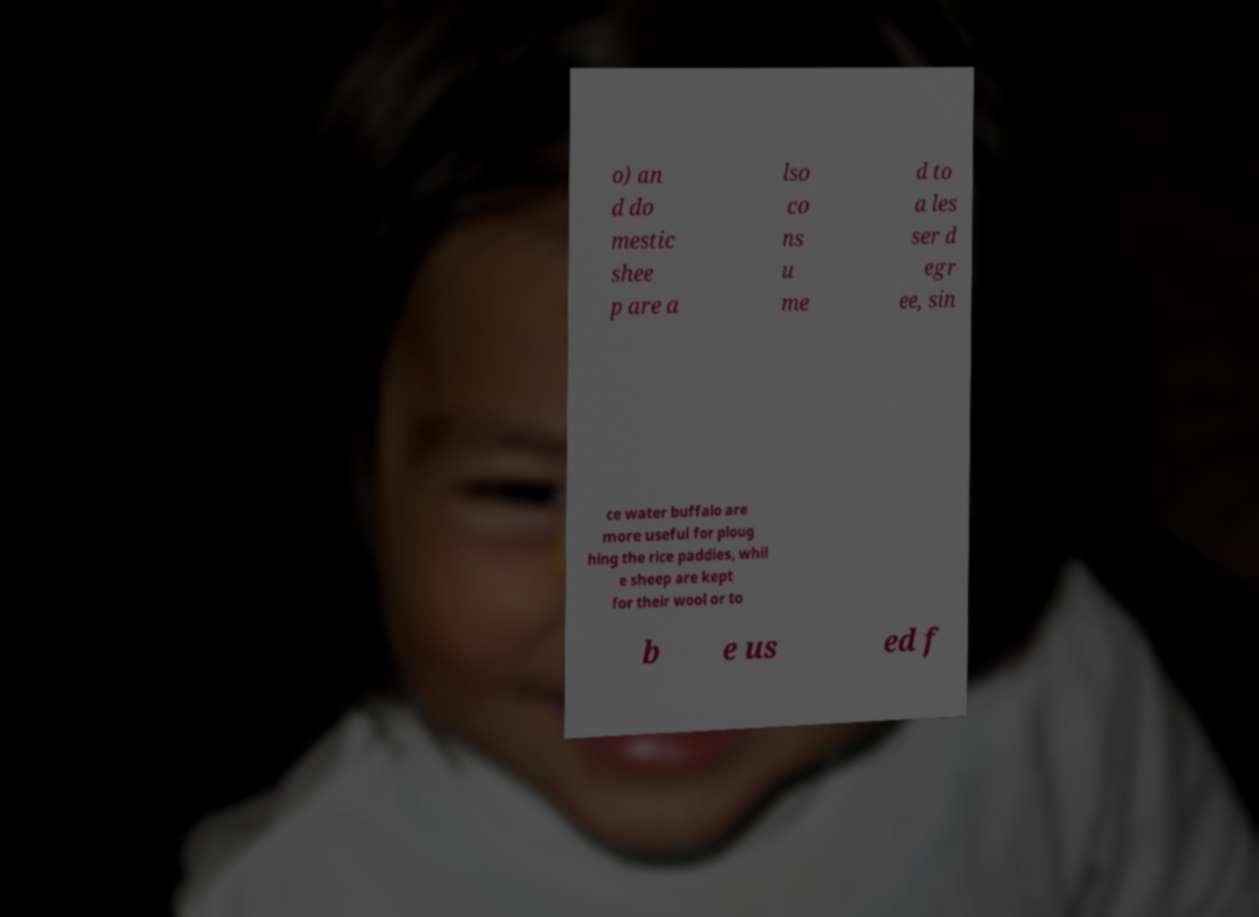Can you read and provide the text displayed in the image?This photo seems to have some interesting text. Can you extract and type it out for me? o) an d do mestic shee p are a lso co ns u me d to a les ser d egr ee, sin ce water buffalo are more useful for ploug hing the rice paddies, whil e sheep are kept for their wool or to b e us ed f 